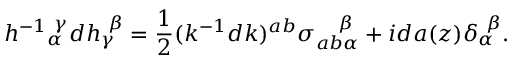Convert formula to latex. <formula><loc_0><loc_0><loc_500><loc_500>h ^ { - 1 _ { \alpha } ^ { \gamma } d h _ { \gamma } ^ { \beta } = { \frac { 1 } { 2 } } ( k ^ { - 1 } d k ) ^ { a b } \sigma _ { a b \alpha } ^ { \beta } + i d a ( z ) \delta _ { \alpha } ^ { \beta } .</formula> 